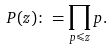Convert formula to latex. <formula><loc_0><loc_0><loc_500><loc_500>P ( z ) \colon = \prod _ { p \leqslant z } p .</formula> 